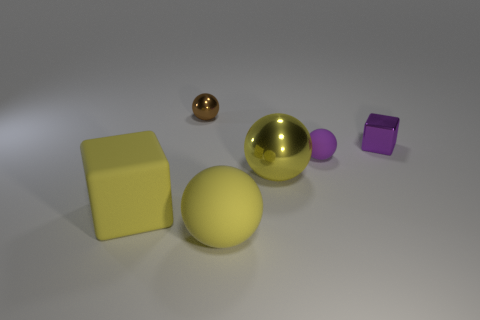There is a brown ball; is its size the same as the purple block in front of the small brown sphere?
Your answer should be very brief. Yes. What material is the small purple object that is the same shape as the tiny brown thing?
Keep it short and to the point. Rubber. How big is the metallic sphere that is on the left side of the big rubber thing on the right side of the tiny metal object behind the tiny cube?
Your response must be concise. Small. Is the size of the rubber block the same as the yellow matte sphere?
Your response must be concise. Yes. What is the material of the tiny ball to the left of the rubber ball behind the big metallic thing?
Ensure brevity in your answer.  Metal. There is a big yellow rubber object that is to the left of the yellow matte sphere; is its shape the same as the metal object behind the small purple cube?
Keep it short and to the point. No. Are there the same number of small purple shiny things in front of the large metal sphere and brown metal things?
Give a very brief answer. No. Are there any big yellow metallic objects that are behind the cube to the left of the purple matte object?
Provide a succinct answer. Yes. Is there any other thing that has the same color as the large shiny ball?
Your answer should be compact. Yes. Are the large yellow thing that is left of the brown shiny object and the small brown ball made of the same material?
Give a very brief answer. No. 